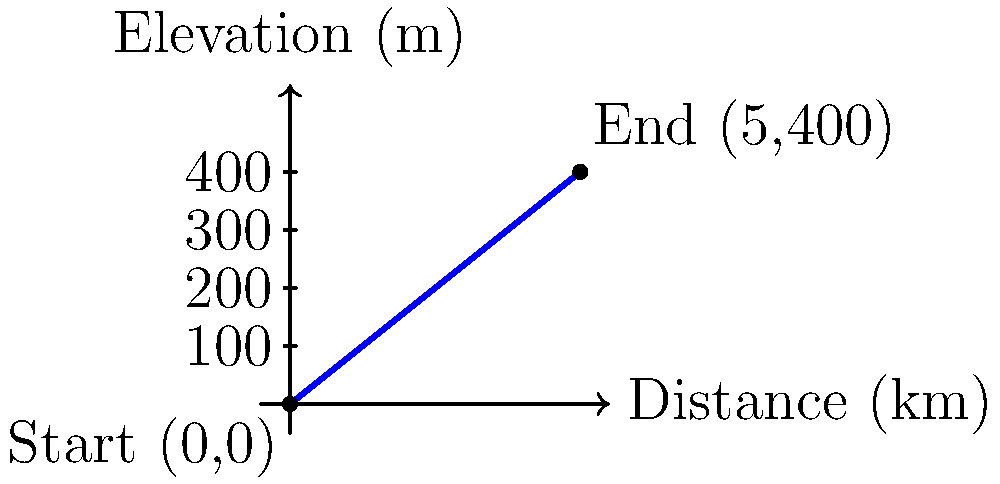As a park ranger at Stark Parks, you're tasked with assessing the difficulty of a new hiking trail. The trail starts at an elevation of 0 meters and ends at 400 meters, covering a horizontal distance of 5 kilometers. Calculate the slope of this trail as a percentage. To calculate the slope of the hiking trail as a percentage, we'll follow these steps:

1) Identify the key information:
   - Elevation change (rise): 400 meters
   - Horizontal distance (run): 5 kilometers = 5000 meters

2) Calculate the slope using the formula:
   $\text{Slope} = \frac{\text{Rise}}{\text{Run}}$

3) Plug in the values:
   $\text{Slope} = \frac{400 \text{ m}}{5000 \text{ m}} = 0.08$

4) Convert the slope to a percentage:
   $\text{Slope percentage} = \text{Slope} \times 100\%$
   $\text{Slope percentage} = 0.08 \times 100\% = 8\%$

Therefore, the slope of the hiking trail is 8%.
Answer: 8% 